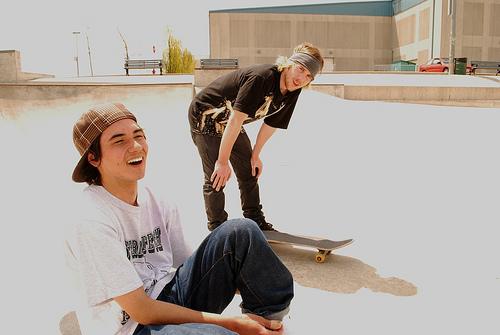What is tied around the man in black head?
Concise answer only. Bandana. What color is the boys hat?
Give a very brief answer. Brown. Are both people laughing?
Quick response, please. No. 